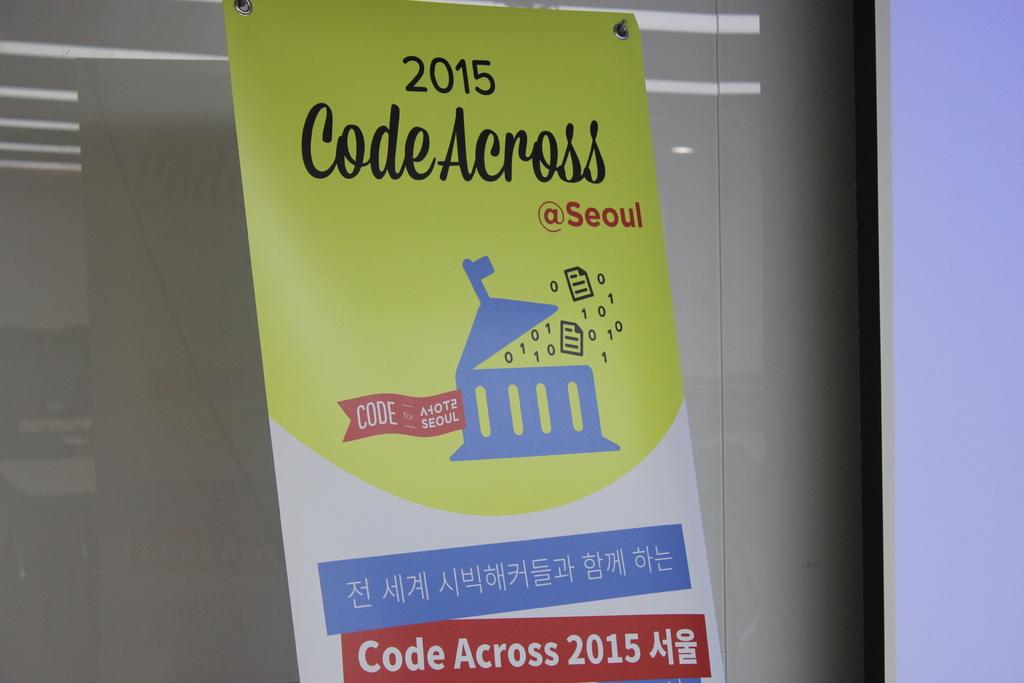<image>
Provide a brief description of the given image. Sign on a wall that says 2015 Codew Across. 